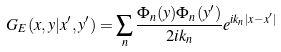<formula> <loc_0><loc_0><loc_500><loc_500>G _ { E } ( x , y | x ^ { \prime } , y ^ { \prime } ) = \sum _ { n } \frac { \Phi _ { n } ( y ) \Phi _ { n } ( y ^ { \prime } ) } { 2 i k _ { n } } e ^ { i k _ { n } | x - x ^ { \prime } | }</formula> 